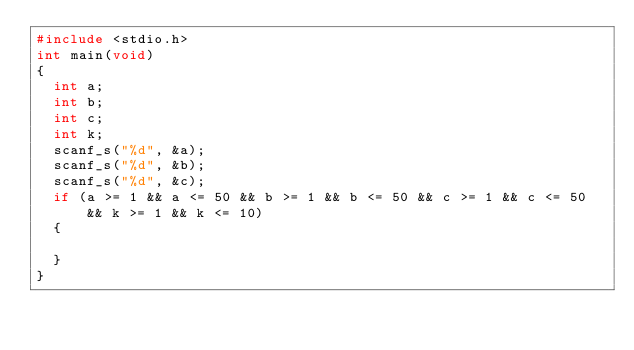<code> <loc_0><loc_0><loc_500><loc_500><_C_>#include <stdio.h>
int main(void)
{
	int a;
	int b;
	int c;
	int k;
	scanf_s("%d", &a);
	scanf_s("%d", &b);
	scanf_s("%d", &c);
	if (a >= 1 && a <= 50 && b >= 1 && b <= 50 && c >= 1 && c <= 50 && k >= 1 && k <= 10)
	{

	}
}</code> 